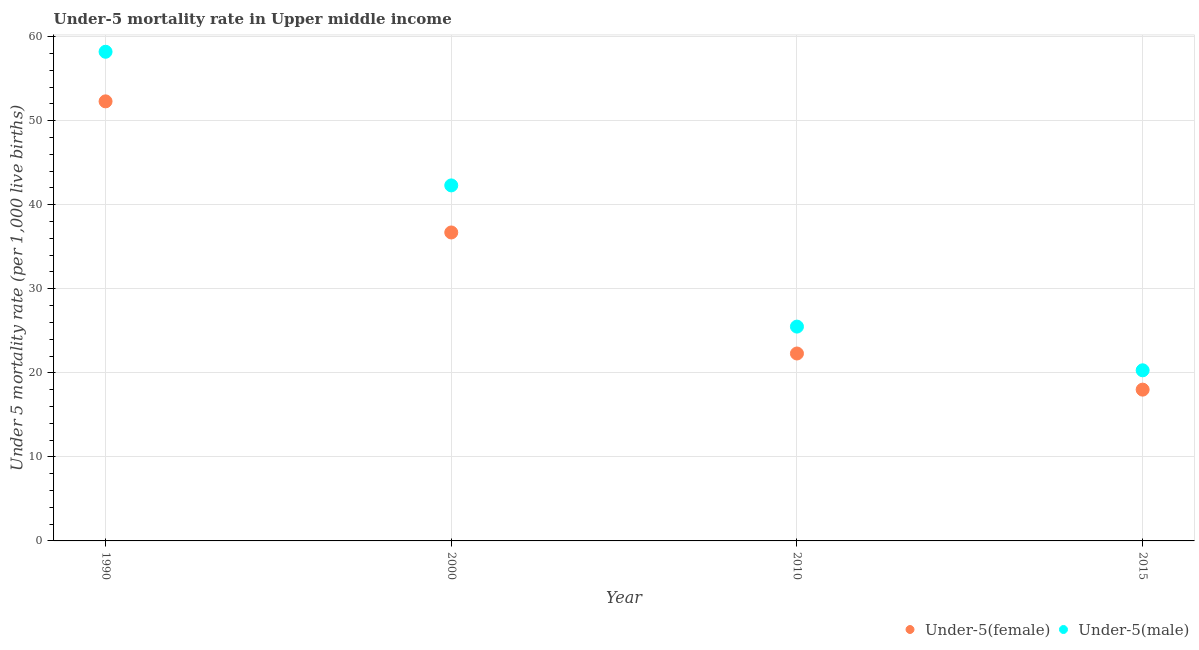How many different coloured dotlines are there?
Ensure brevity in your answer.  2. What is the under-5 male mortality rate in 2000?
Give a very brief answer. 42.3. Across all years, what is the maximum under-5 female mortality rate?
Give a very brief answer. 52.3. In which year was the under-5 female mortality rate minimum?
Keep it short and to the point. 2015. What is the total under-5 female mortality rate in the graph?
Your response must be concise. 129.3. What is the difference between the under-5 male mortality rate in 2000 and that in 2015?
Provide a succinct answer. 22. What is the average under-5 female mortality rate per year?
Your answer should be very brief. 32.33. In the year 2015, what is the difference between the under-5 female mortality rate and under-5 male mortality rate?
Make the answer very short. -2.3. In how many years, is the under-5 female mortality rate greater than 14?
Your answer should be compact. 4. What is the ratio of the under-5 female mortality rate in 1990 to that in 2010?
Offer a terse response. 2.35. Is the difference between the under-5 female mortality rate in 1990 and 2015 greater than the difference between the under-5 male mortality rate in 1990 and 2015?
Provide a short and direct response. No. What is the difference between the highest and the second highest under-5 female mortality rate?
Your answer should be compact. 15.6. What is the difference between the highest and the lowest under-5 male mortality rate?
Ensure brevity in your answer.  37.9. In how many years, is the under-5 female mortality rate greater than the average under-5 female mortality rate taken over all years?
Make the answer very short. 2. Is the under-5 female mortality rate strictly greater than the under-5 male mortality rate over the years?
Ensure brevity in your answer.  No. Is the under-5 male mortality rate strictly less than the under-5 female mortality rate over the years?
Give a very brief answer. No. What is the difference between two consecutive major ticks on the Y-axis?
Ensure brevity in your answer.  10. Are the values on the major ticks of Y-axis written in scientific E-notation?
Keep it short and to the point. No. Does the graph contain any zero values?
Your response must be concise. No. What is the title of the graph?
Your answer should be very brief. Under-5 mortality rate in Upper middle income. Does "Forest" appear as one of the legend labels in the graph?
Your answer should be compact. No. What is the label or title of the Y-axis?
Provide a short and direct response. Under 5 mortality rate (per 1,0 live births). What is the Under 5 mortality rate (per 1,000 live births) in Under-5(female) in 1990?
Provide a short and direct response. 52.3. What is the Under 5 mortality rate (per 1,000 live births) of Under-5(male) in 1990?
Provide a succinct answer. 58.2. What is the Under 5 mortality rate (per 1,000 live births) in Under-5(female) in 2000?
Offer a very short reply. 36.7. What is the Under 5 mortality rate (per 1,000 live births) of Under-5(male) in 2000?
Ensure brevity in your answer.  42.3. What is the Under 5 mortality rate (per 1,000 live births) in Under-5(female) in 2010?
Provide a succinct answer. 22.3. What is the Under 5 mortality rate (per 1,000 live births) in Under-5(female) in 2015?
Your answer should be compact. 18. What is the Under 5 mortality rate (per 1,000 live births) in Under-5(male) in 2015?
Your answer should be very brief. 20.3. Across all years, what is the maximum Under 5 mortality rate (per 1,000 live births) in Under-5(female)?
Provide a succinct answer. 52.3. Across all years, what is the maximum Under 5 mortality rate (per 1,000 live births) of Under-5(male)?
Offer a very short reply. 58.2. Across all years, what is the minimum Under 5 mortality rate (per 1,000 live births) in Under-5(female)?
Keep it short and to the point. 18. Across all years, what is the minimum Under 5 mortality rate (per 1,000 live births) in Under-5(male)?
Your answer should be very brief. 20.3. What is the total Under 5 mortality rate (per 1,000 live births) in Under-5(female) in the graph?
Keep it short and to the point. 129.3. What is the total Under 5 mortality rate (per 1,000 live births) of Under-5(male) in the graph?
Ensure brevity in your answer.  146.3. What is the difference between the Under 5 mortality rate (per 1,000 live births) of Under-5(male) in 1990 and that in 2010?
Offer a very short reply. 32.7. What is the difference between the Under 5 mortality rate (per 1,000 live births) of Under-5(female) in 1990 and that in 2015?
Provide a short and direct response. 34.3. What is the difference between the Under 5 mortality rate (per 1,000 live births) in Under-5(male) in 1990 and that in 2015?
Offer a terse response. 37.9. What is the difference between the Under 5 mortality rate (per 1,000 live births) in Under-5(female) in 1990 and the Under 5 mortality rate (per 1,000 live births) in Under-5(male) in 2010?
Keep it short and to the point. 26.8. What is the difference between the Under 5 mortality rate (per 1,000 live births) in Under-5(female) in 1990 and the Under 5 mortality rate (per 1,000 live births) in Under-5(male) in 2015?
Keep it short and to the point. 32. What is the difference between the Under 5 mortality rate (per 1,000 live births) in Under-5(female) in 2000 and the Under 5 mortality rate (per 1,000 live births) in Under-5(male) in 2015?
Offer a very short reply. 16.4. What is the average Under 5 mortality rate (per 1,000 live births) in Under-5(female) per year?
Offer a terse response. 32.33. What is the average Under 5 mortality rate (per 1,000 live births) in Under-5(male) per year?
Your answer should be very brief. 36.58. In the year 1990, what is the difference between the Under 5 mortality rate (per 1,000 live births) of Under-5(female) and Under 5 mortality rate (per 1,000 live births) of Under-5(male)?
Provide a short and direct response. -5.9. In the year 2000, what is the difference between the Under 5 mortality rate (per 1,000 live births) in Under-5(female) and Under 5 mortality rate (per 1,000 live births) in Under-5(male)?
Ensure brevity in your answer.  -5.6. In the year 2015, what is the difference between the Under 5 mortality rate (per 1,000 live births) in Under-5(female) and Under 5 mortality rate (per 1,000 live births) in Under-5(male)?
Your response must be concise. -2.3. What is the ratio of the Under 5 mortality rate (per 1,000 live births) of Under-5(female) in 1990 to that in 2000?
Offer a terse response. 1.43. What is the ratio of the Under 5 mortality rate (per 1,000 live births) of Under-5(male) in 1990 to that in 2000?
Your answer should be compact. 1.38. What is the ratio of the Under 5 mortality rate (per 1,000 live births) in Under-5(female) in 1990 to that in 2010?
Your answer should be very brief. 2.35. What is the ratio of the Under 5 mortality rate (per 1,000 live births) of Under-5(male) in 1990 to that in 2010?
Provide a succinct answer. 2.28. What is the ratio of the Under 5 mortality rate (per 1,000 live births) of Under-5(female) in 1990 to that in 2015?
Your answer should be compact. 2.91. What is the ratio of the Under 5 mortality rate (per 1,000 live births) of Under-5(male) in 1990 to that in 2015?
Your response must be concise. 2.87. What is the ratio of the Under 5 mortality rate (per 1,000 live births) in Under-5(female) in 2000 to that in 2010?
Provide a short and direct response. 1.65. What is the ratio of the Under 5 mortality rate (per 1,000 live births) of Under-5(male) in 2000 to that in 2010?
Provide a short and direct response. 1.66. What is the ratio of the Under 5 mortality rate (per 1,000 live births) of Under-5(female) in 2000 to that in 2015?
Offer a very short reply. 2.04. What is the ratio of the Under 5 mortality rate (per 1,000 live births) of Under-5(male) in 2000 to that in 2015?
Your answer should be very brief. 2.08. What is the ratio of the Under 5 mortality rate (per 1,000 live births) of Under-5(female) in 2010 to that in 2015?
Give a very brief answer. 1.24. What is the ratio of the Under 5 mortality rate (per 1,000 live births) of Under-5(male) in 2010 to that in 2015?
Offer a terse response. 1.26. What is the difference between the highest and the lowest Under 5 mortality rate (per 1,000 live births) in Under-5(female)?
Your response must be concise. 34.3. What is the difference between the highest and the lowest Under 5 mortality rate (per 1,000 live births) of Under-5(male)?
Give a very brief answer. 37.9. 